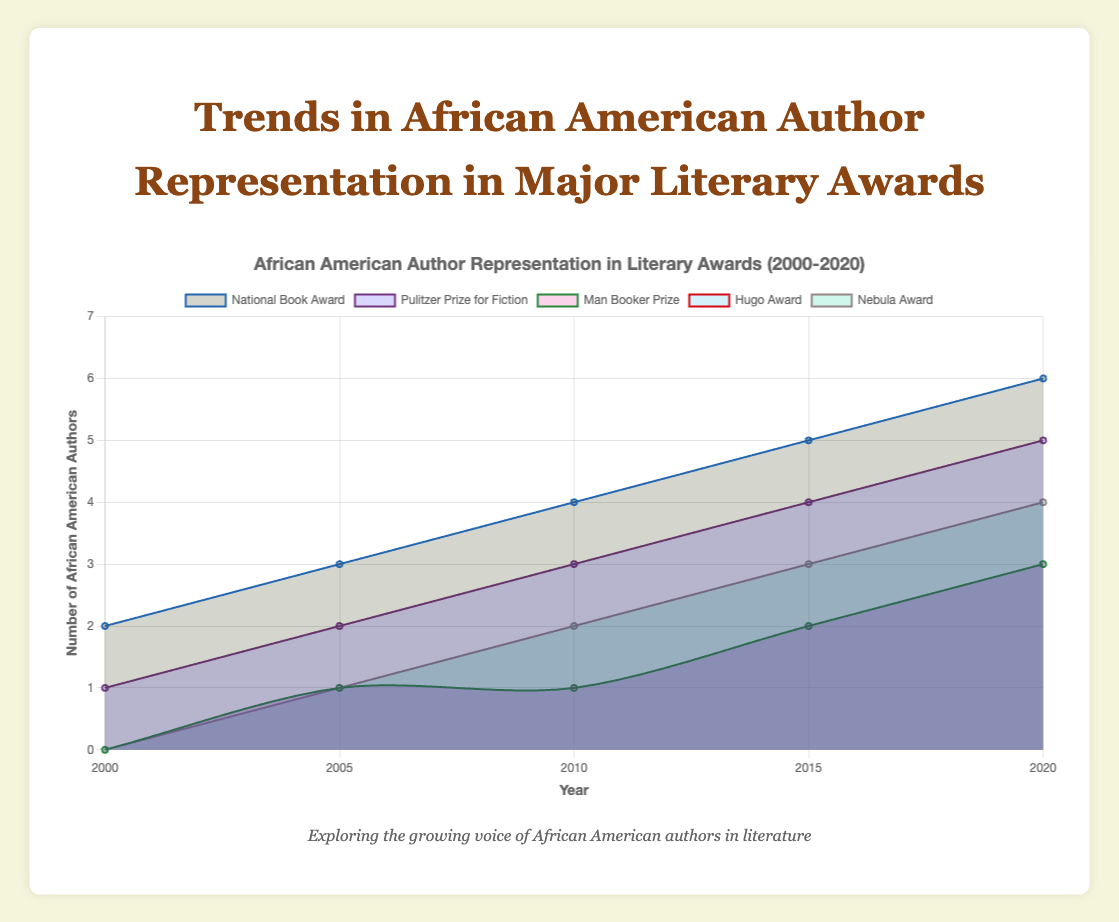What is the title of the chart? The title is displayed prominently at the top of the chart and reads "Trends in African American Author Representation in Major Literary Awards."
Answer: "Trends in African American Author Representation in Major Literary Awards" How many different awards are represented in the chart? By visually counting each distinct line in the chart, we determine that five different awards are represented.
Answer: Five Which award had no African American author representation in the year 2000? Observing the y-axis values for the year 2000, the Man Booker Prize, Hugo Award, and Nebula Award all started with a count of 0.
Answer: Man Booker Prize, Hugo Award, Nebula Award How many African American authors in total won the National Book Award from 2000 to 2020? Summing up the data points for the National Book Award over the years: 2 + 3 + 4 + 5 + 6 = 20
Answer: 20 Which award saw the largest increase in African American authors from 2000 to 2020? To find this, compare the numbers in 2000 and 2020 for each award. The National Book Award increased by 4, the Pulitzer Prize for Fiction by 4, the Man Booker Prize by 3, the Hugo Award by 3, and the Nebula Award by 4. Several awards saw the same increase, but they need a secondary check. The largest, considering starting points, is even across four awards.
Answer: National Book Award, Pulitzer Prize for Fiction, Man Booker Prize, Hugo Award, Nebula Award By how much did representation in the Hugo Award increase between each time interval (2000, 2005, 2010, 2015, 2020)? Subtract consecutive data points in the counts: 2005-2000 (1-0=1), 2010-2005 (1-1=0), 2015-2010 (2-1=1), and 2020-2015 (3-2=1). The increases are 1, 0, 1, and 1 respectively.
Answer: 1, 0, 1, 1 Which award had the highest number of African American authors in the year 2020? Comparing the values for all awards in 2020, the highest count is for the National Book Award with 6 authors.
Answer: National Book Award Which awards had exactly 1 African American author in the year 2005? Observing the counts for 2005, the Man Booker Prize, Hugo Award, and Nebula Award each had 1 African American author.
Answer: Man Booker Prize, Hugo Award, Nebula Award What was the total representation of African American authors across all awards in 2015? Adding the counts from all awards for the year 2015: 5 (National Book Award) + 4 (Pulitzer Prize for Fiction) + 2 (Man Booker Prize) + 2 (Hugo Award) + 3 (Nebula Award) gives 16.
Answer: 16 